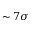<formula> <loc_0><loc_0><loc_500><loc_500>\sim 7 \sigma</formula> 